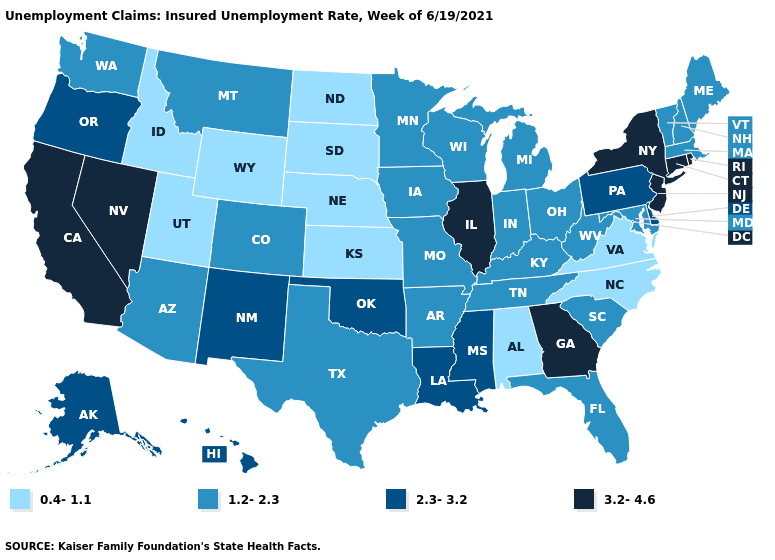What is the value of Louisiana?
Be succinct. 2.3-3.2. Name the states that have a value in the range 1.2-2.3?
Concise answer only. Arizona, Arkansas, Colorado, Florida, Indiana, Iowa, Kentucky, Maine, Maryland, Massachusetts, Michigan, Minnesota, Missouri, Montana, New Hampshire, Ohio, South Carolina, Tennessee, Texas, Vermont, Washington, West Virginia, Wisconsin. What is the lowest value in the South?
Keep it brief. 0.4-1.1. Name the states that have a value in the range 1.2-2.3?
Quick response, please. Arizona, Arkansas, Colorado, Florida, Indiana, Iowa, Kentucky, Maine, Maryland, Massachusetts, Michigan, Minnesota, Missouri, Montana, New Hampshire, Ohio, South Carolina, Tennessee, Texas, Vermont, Washington, West Virginia, Wisconsin. Does the first symbol in the legend represent the smallest category?
Concise answer only. Yes. What is the value of Arkansas?
Short answer required. 1.2-2.3. What is the value of Virginia?
Keep it brief. 0.4-1.1. Does Hawaii have the lowest value in the USA?
Write a very short answer. No. Does Maryland have a lower value than Texas?
Be succinct. No. Which states have the highest value in the USA?
Answer briefly. California, Connecticut, Georgia, Illinois, Nevada, New Jersey, New York, Rhode Island. Name the states that have a value in the range 2.3-3.2?
Keep it brief. Alaska, Delaware, Hawaii, Louisiana, Mississippi, New Mexico, Oklahoma, Oregon, Pennsylvania. Name the states that have a value in the range 0.4-1.1?
Concise answer only. Alabama, Idaho, Kansas, Nebraska, North Carolina, North Dakota, South Dakota, Utah, Virginia, Wyoming. What is the value of New Jersey?
Answer briefly. 3.2-4.6. What is the lowest value in the Northeast?
Short answer required. 1.2-2.3. What is the value of New Jersey?
Answer briefly. 3.2-4.6. 